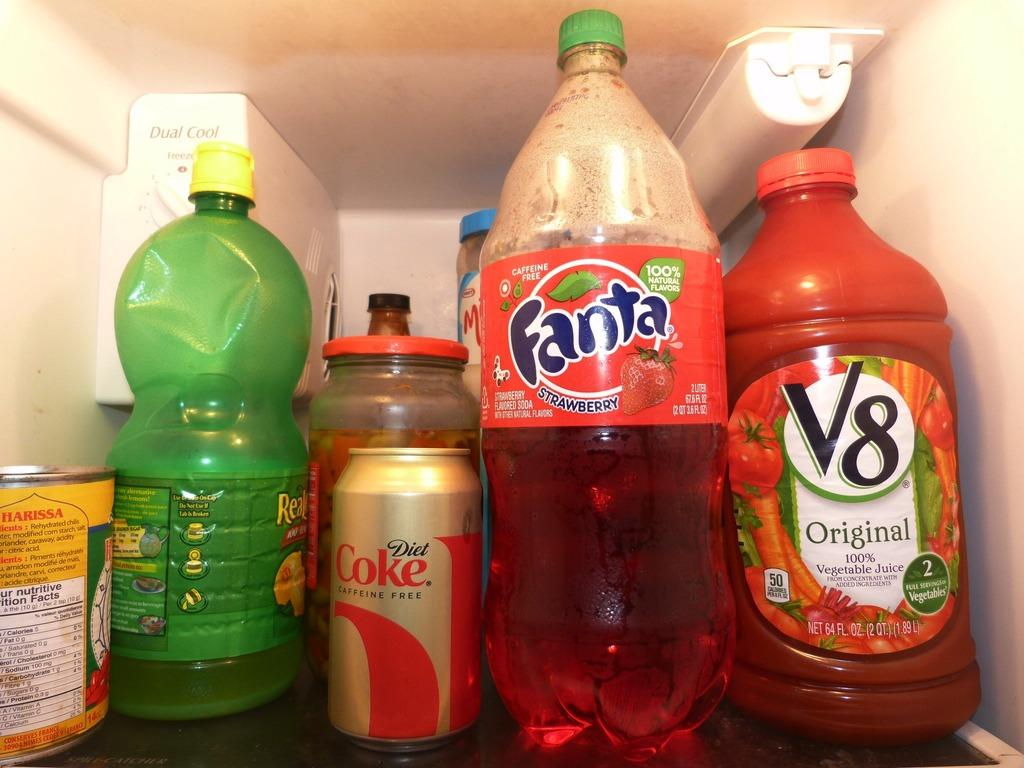<image>
Present a compact description of the photo's key features. Bottles of Real Lemon, Fanta, V8, and a can of coke sit on a shelf in the fridge. 